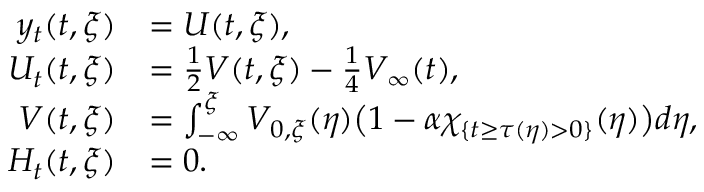<formula> <loc_0><loc_0><loc_500><loc_500>\begin{array} { r l } { y _ { t } ( t , \xi ) } & { = U ( t , \xi ) , } \\ { U _ { t } ( t , \xi ) } & { = \frac { 1 } { 2 } V ( t , \xi ) - \frac { 1 } { 4 } V _ { \infty } ( t ) , } \\ { V ( t , \xi ) } & { = \int _ { - \infty } ^ { \xi } V _ { 0 , \xi } ( \eta ) \left ( 1 - \alpha \chi _ { \{ t \geq \tau ( \eta ) > 0 \} } ( \eta ) \right ) d \eta , } \\ { H _ { t } ( t , \xi ) } & { = 0 . } \end{array}</formula> 